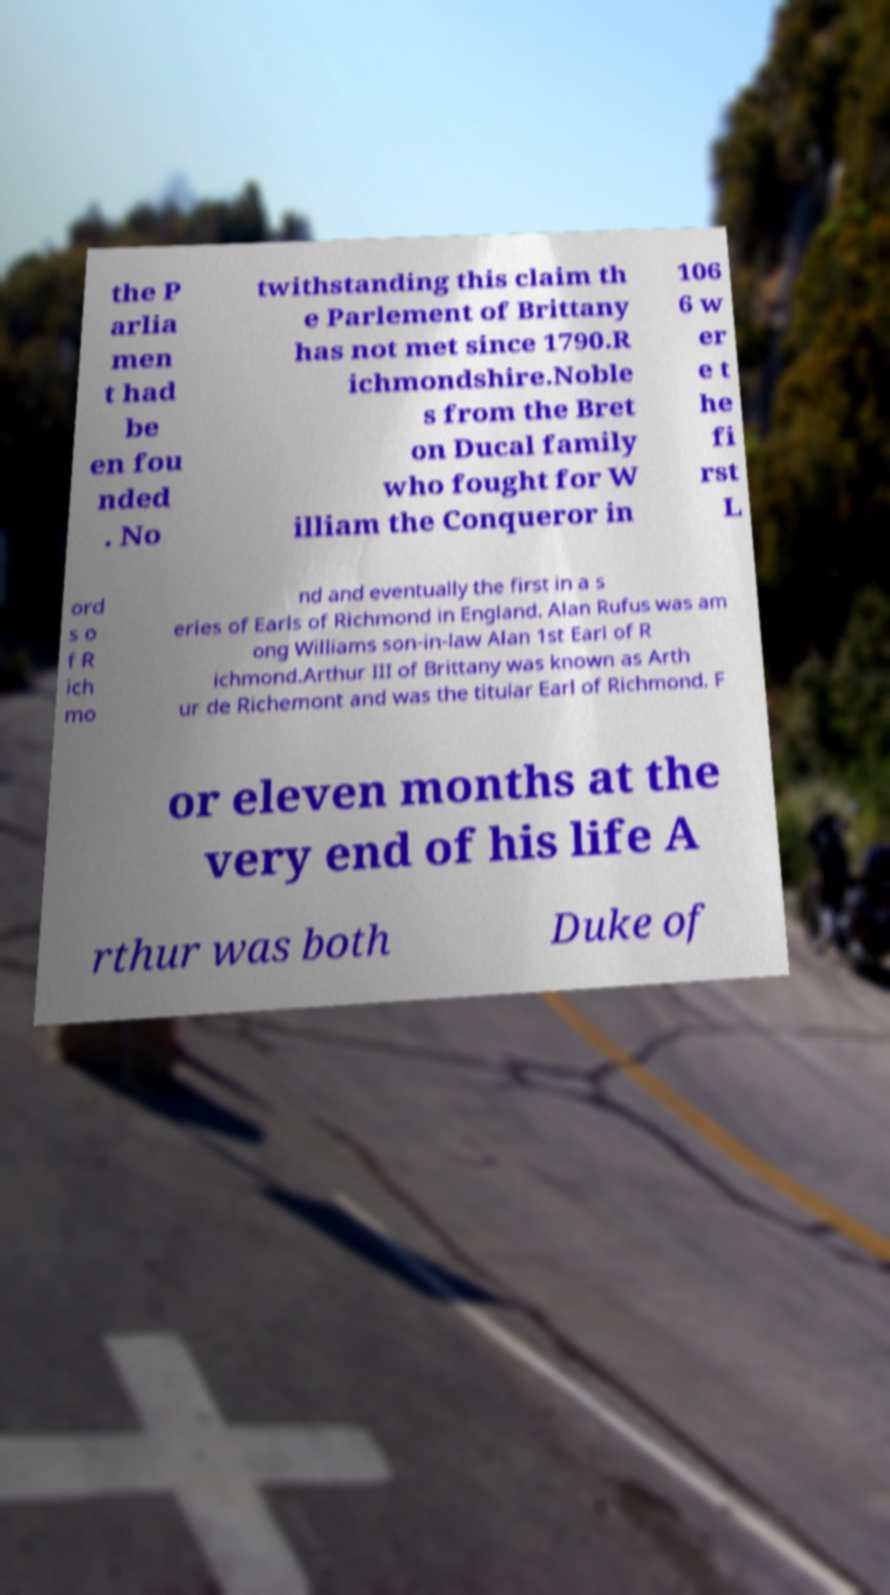I need the written content from this picture converted into text. Can you do that? the P arlia men t had be en fou nded . No twithstanding this claim th e Parlement of Brittany has not met since 1790.R ichmondshire.Noble s from the Bret on Ducal family who fought for W illiam the Conqueror in 106 6 w er e t he fi rst L ord s o f R ich mo nd and eventually the first in a s eries of Earls of Richmond in England. Alan Rufus was am ong Williams son-in-law Alan 1st Earl of R ichmond.Arthur III of Brittany was known as Arth ur de Richemont and was the titular Earl of Richmond. F or eleven months at the very end of his life A rthur was both Duke of 